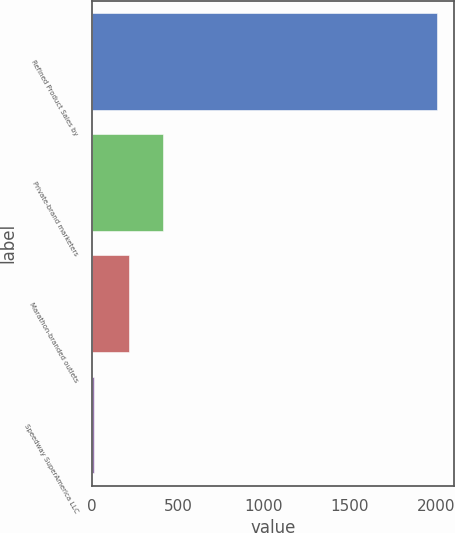Convert chart. <chart><loc_0><loc_0><loc_500><loc_500><bar_chart><fcel>Refined Product Sales by<fcel>Private-brand marketers<fcel>Marathon-branded outlets<fcel>Speedway SuperAmerica LLC<nl><fcel>2007<fcel>413.4<fcel>214.2<fcel>15<nl></chart> 